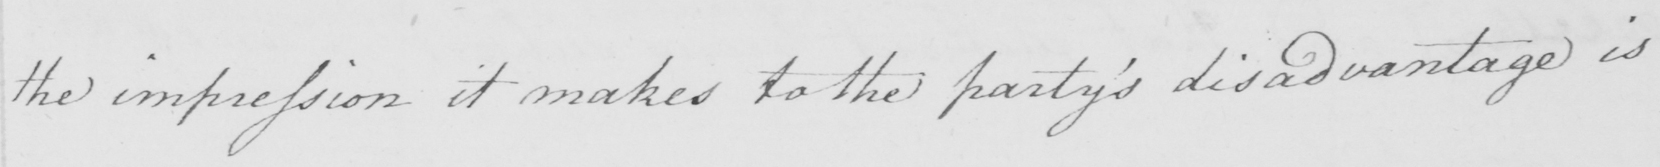What does this handwritten line say? the impression it makes to the party ' s disadvantage is 